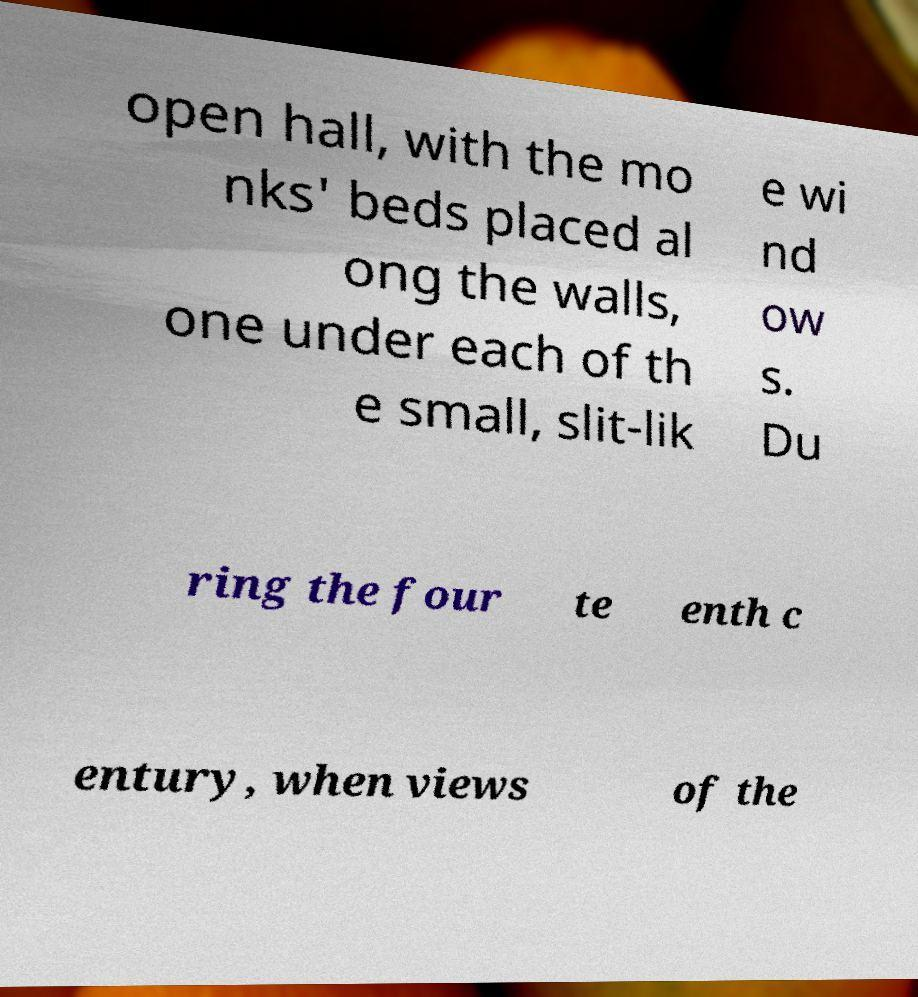Please identify and transcribe the text found in this image. open hall, with the mo nks' beds placed al ong the walls, one under each of th e small, slit-lik e wi nd ow s. Du ring the four te enth c entury, when views of the 